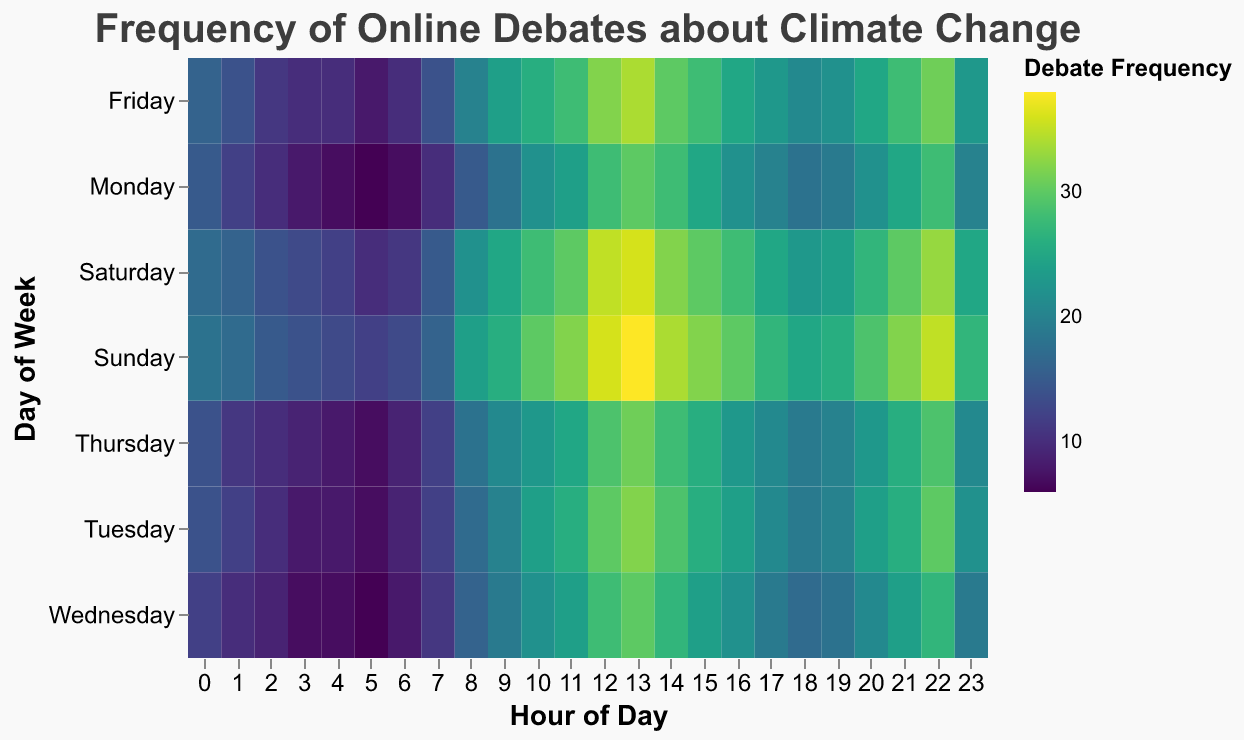What is the title of the heatmap? The title of the heatmap is prominently displayed at the top of the figure, which is "Frequency of Online Debates about Climate Change."
Answer: Frequency of Online Debates about Climate Change What does the color scheme (legend) represent in the heatmap? The color scheme represents the "Debate Frequency." Different colors indicate different frequencies of debates, with the actual frequency values mapped onto the color spectrum shown in the legend.
Answer: Debate Frequency Which day has the highest frequency of online debates during the 12 PM hour? According to the color representation on the heatmap, the frequency values can be seen on Sunday. The highest value for the 12 PM hour is 36.
Answer: Sunday What is the overall trend in debate frequency from 0 AM to 6 AM across the week? From 0 AM to 6 AM, the heatmap shows that the debate frequency tends to be lower. The values range from 6 to 13, indicating a general trend of lower activity during these early hours.
Answer: Lower debate frequency Which hour on Friday has the highest debate frequency? By examining the heatmap's color intensity and referring to the corresponding hours, the highest debate frequency on Friday occurs at 12 PM with a value of 32.
Answer: 12 PM Overall, which day of the week tends to have the highest frequency of online debates? By looking at the heatmap, Sunday generally shows the highest frequency across most hours, especially from the afternoon onwards. Most of the high values are on Sunday.
Answer: Sunday Compare the debate frequency on Monday at 9 AM to that on Wednesday at the same time. On the heatmap, Monday at 9 AM has a debate frequency of 18, while Wednesday at 9 AM has a debate frequency of 19. Therefore, Wednesday has a slightly higher frequency.
Answer: Wednesday What is the average debate frequency at 3 PM over all days of the week? To find the average, sum the frequencies at 3 PM (25, 26, 24, 26, 28, 30, 32) and divide by 7. Total sum = 191, Average = 191/7 ≈ 27.29
Answer: 27.29 Is the frequency of debates generally higher in the morning or the evening on Saturdays? By comparing morning (6 AM to 12 PM) and evening (6 PM to 12 AM) frequencies on Saturday, the values are higher in the morning (11 to 30) than in the evening (23 to 33). Hence, the morning shows a generally higher frequency.
Answer: Morning What are the peak hours for debate frequency on Tuesdays? Referring to the heatmap, the peak debate frequencies on Tuesday mostly occur around 12 PM and 1 PM, with values of 30 and 32, respectively.
Answer: 12 PM and 1 PM 